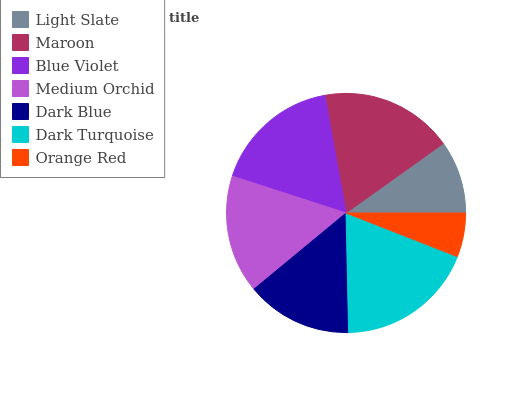Is Orange Red the minimum?
Answer yes or no. Yes. Is Dark Turquoise the maximum?
Answer yes or no. Yes. Is Maroon the minimum?
Answer yes or no. No. Is Maroon the maximum?
Answer yes or no. No. Is Maroon greater than Light Slate?
Answer yes or no. Yes. Is Light Slate less than Maroon?
Answer yes or no. Yes. Is Light Slate greater than Maroon?
Answer yes or no. No. Is Maroon less than Light Slate?
Answer yes or no. No. Is Medium Orchid the high median?
Answer yes or no. Yes. Is Medium Orchid the low median?
Answer yes or no. Yes. Is Blue Violet the high median?
Answer yes or no. No. Is Blue Violet the low median?
Answer yes or no. No. 